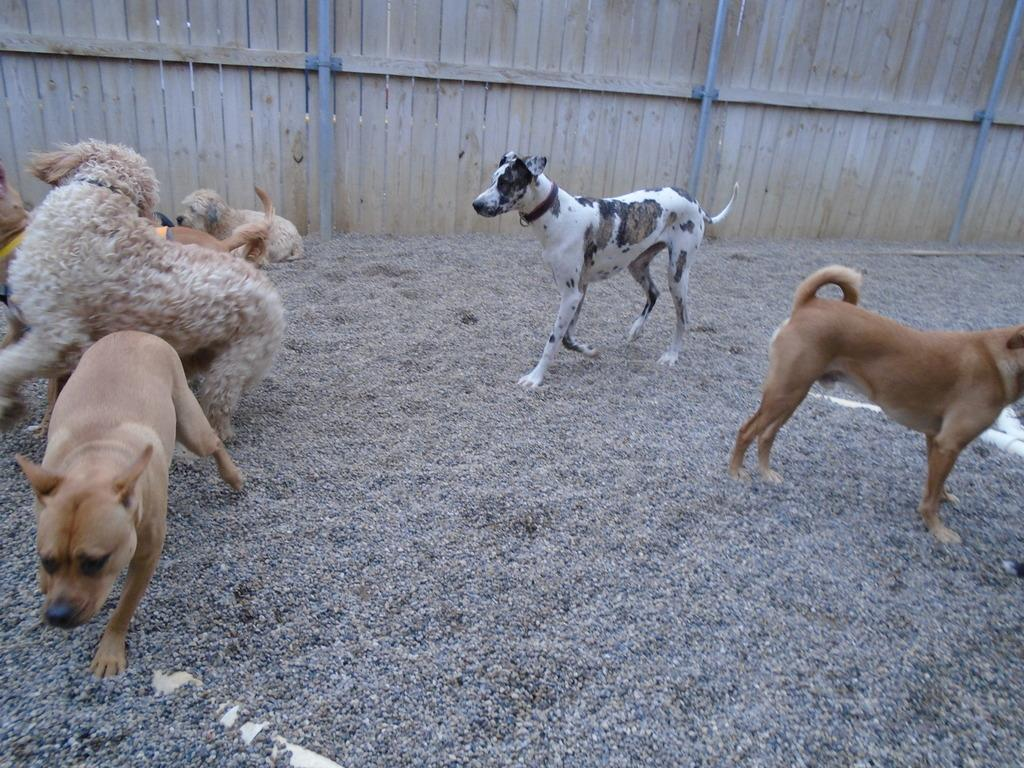What animals are on the ground in the image? There are dogs on the ground in the image. What type of structure is present in the image? There is a wooden wall in the image. Are there any additional features associated with the wooden wall? Yes, there are poles associated with the wooden wall. What type of flowers can be seen growing on the dogs in the image? There are no flowers present in the image, and the dogs do not have any flowers growing on them. 